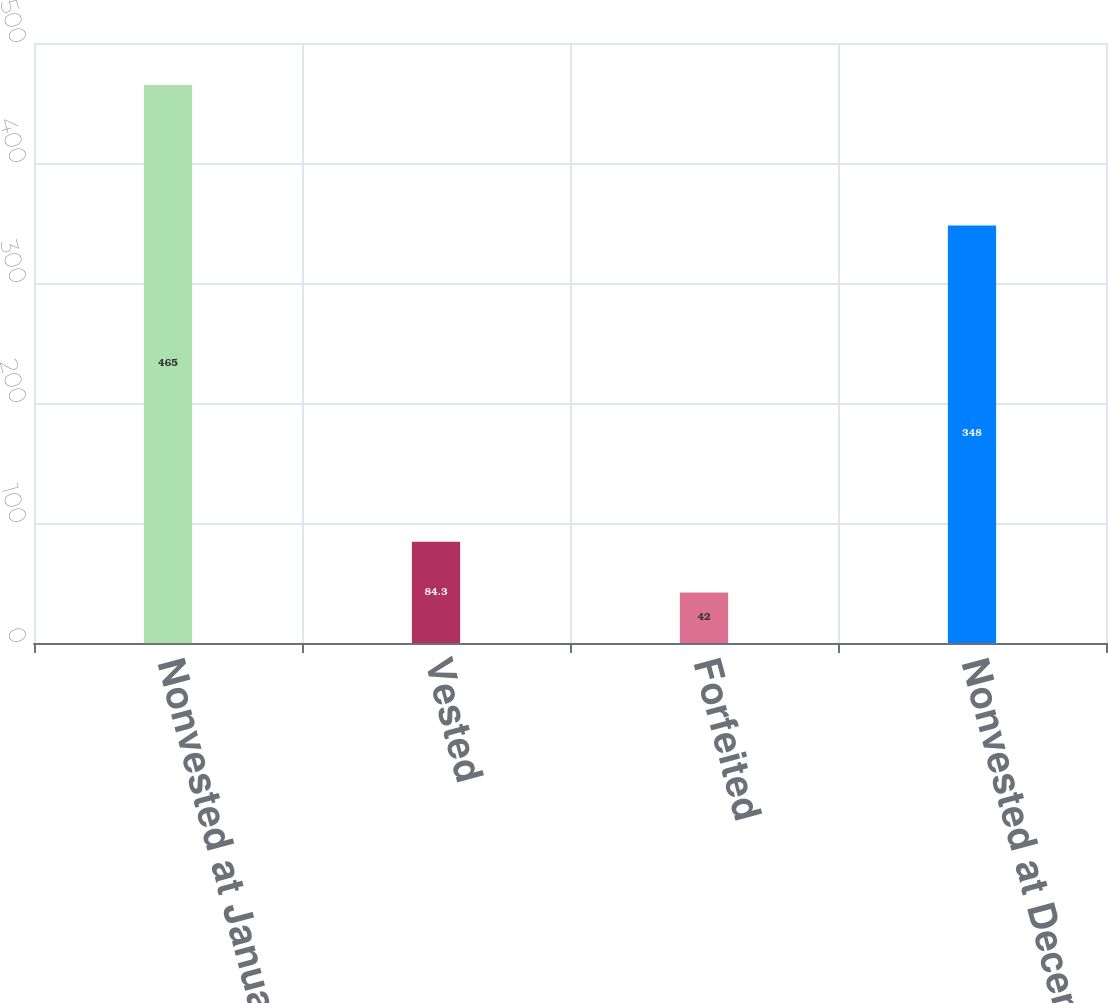Convert chart. <chart><loc_0><loc_0><loc_500><loc_500><bar_chart><fcel>Nonvested at January 1 2007<fcel>Vested<fcel>Forfeited<fcel>Nonvested at December 31 2007<nl><fcel>465<fcel>84.3<fcel>42<fcel>348<nl></chart> 